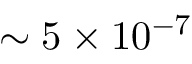<formula> <loc_0><loc_0><loc_500><loc_500>\sim 5 \times 1 0 ^ { - 7 }</formula> 